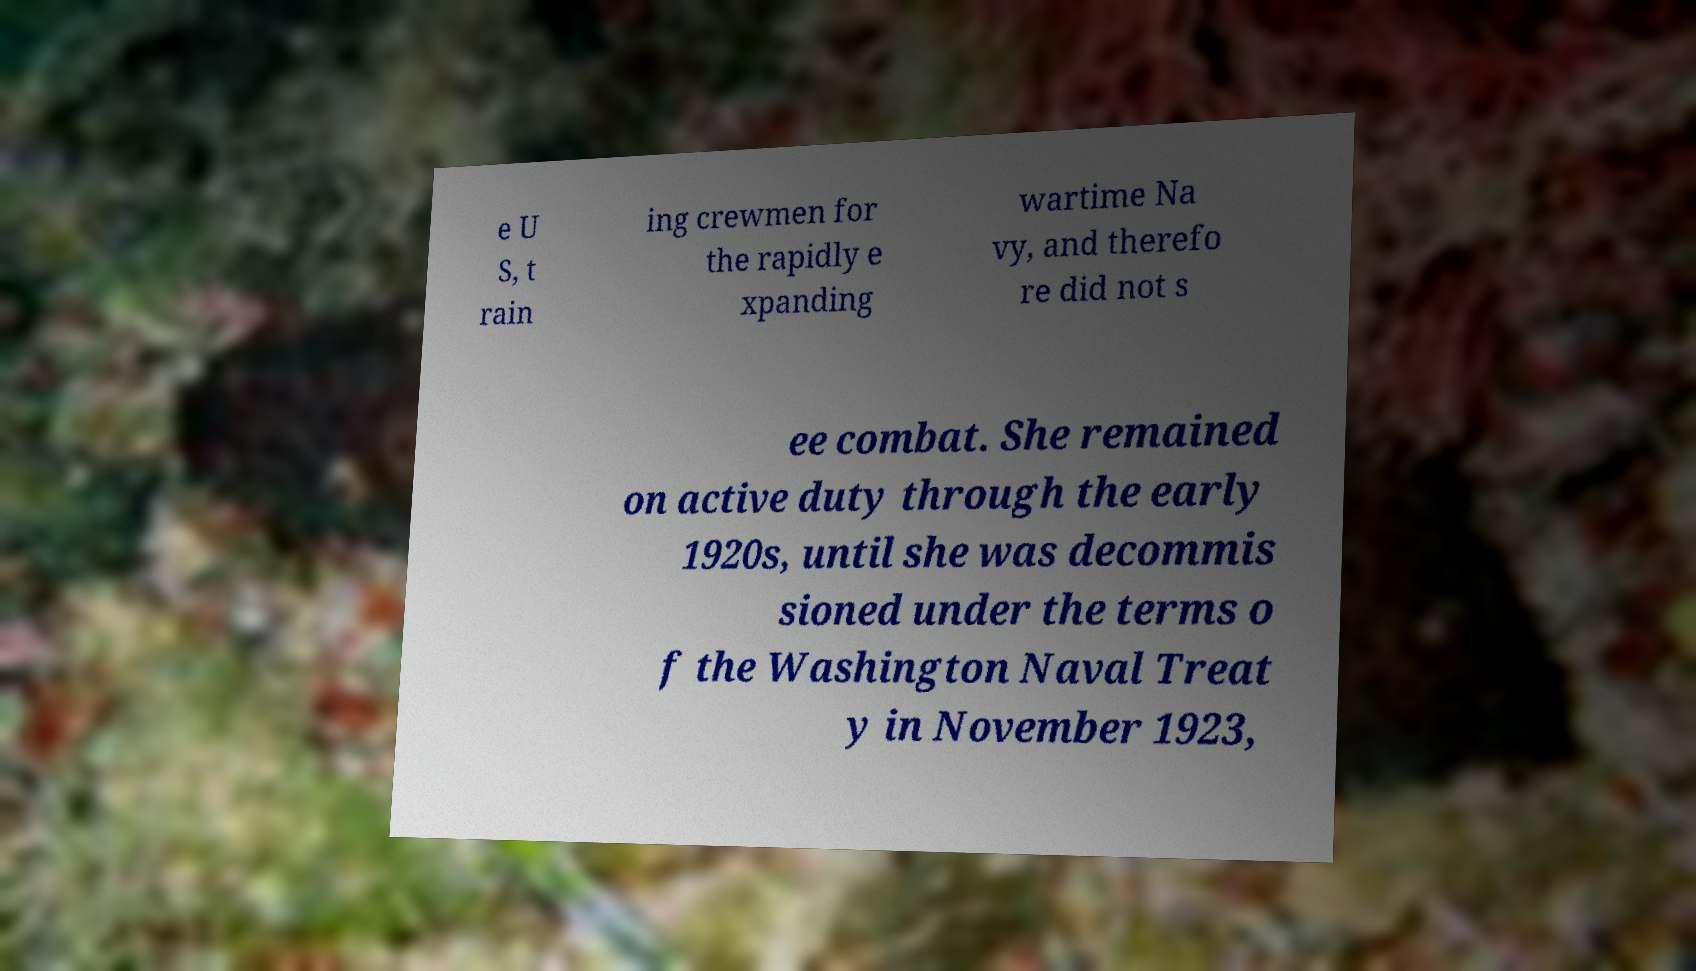Please read and relay the text visible in this image. What does it say? e U S, t rain ing crewmen for the rapidly e xpanding wartime Na vy, and therefo re did not s ee combat. She remained on active duty through the early 1920s, until she was decommis sioned under the terms o f the Washington Naval Treat y in November 1923, 